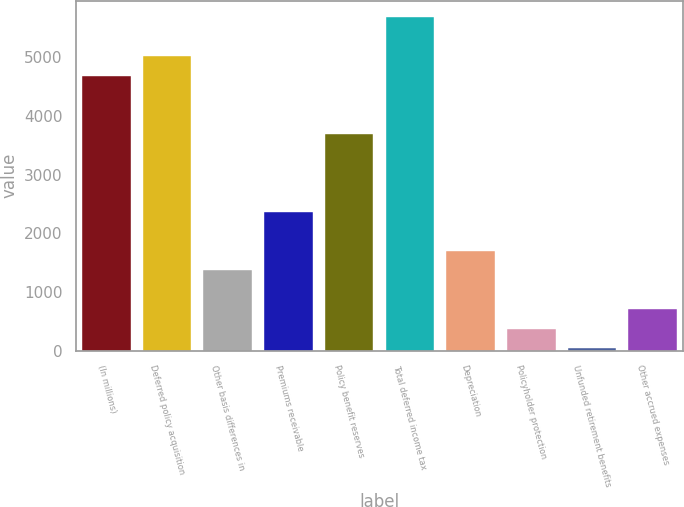Convert chart. <chart><loc_0><loc_0><loc_500><loc_500><bar_chart><fcel>(In millions)<fcel>Deferred policy acquisition<fcel>Other basis differences in<fcel>Premiums receivable<fcel>Policy benefit reserves<fcel>Total deferred income tax<fcel>Depreciation<fcel>Policyholder protection<fcel>Unfunded retirement benefits<fcel>Other accrued expenses<nl><fcel>4683.6<fcel>5015<fcel>1369.6<fcel>2363.8<fcel>3689.4<fcel>5677.8<fcel>1701<fcel>375.4<fcel>44<fcel>706.8<nl></chart> 